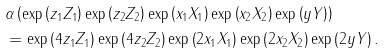Convert formula to latex. <formula><loc_0><loc_0><loc_500><loc_500>& \alpha \left ( \exp \left ( z _ { 1 } Z _ { 1 } \right ) \exp \left ( z _ { 2 } Z _ { 2 } \right ) \exp \left ( x _ { 1 } X _ { 1 } \right ) \exp \left ( x _ { 2 } X _ { 2 } \right ) \exp \left ( y Y \right ) \right ) \\ & = \exp \left ( 4 z _ { 1 } Z _ { 1 } \right ) \exp \left ( 4 z _ { 2 } Z _ { 2 } \right ) \exp \left ( 2 x _ { 1 } X _ { 1 } \right ) \exp \left ( 2 x _ { 2 } X _ { 2 } \right ) \exp \left ( 2 y Y \right ) .</formula> 